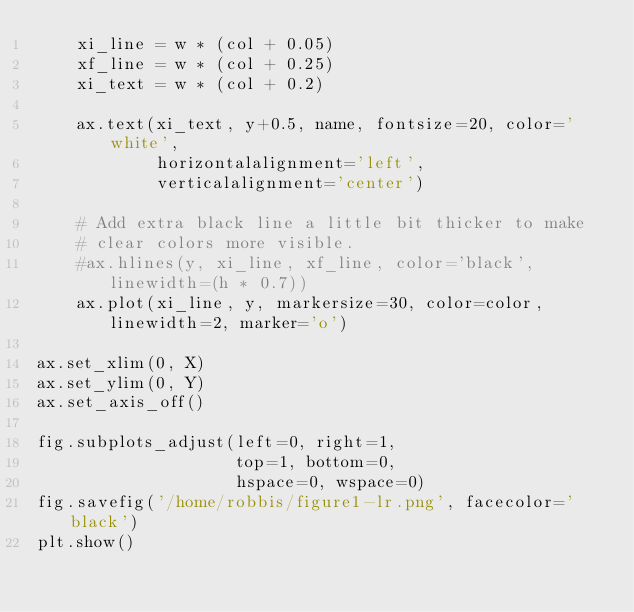Convert code to text. <code><loc_0><loc_0><loc_500><loc_500><_Python_>    xi_line = w * (col + 0.05)
    xf_line = w * (col + 0.25)
    xi_text = w * (col + 0.2)

    ax.text(xi_text, y+0.5, name, fontsize=20, color='white',
            horizontalalignment='left',
            verticalalignment='center')

    # Add extra black line a little bit thicker to make
    # clear colors more visible.
    #ax.hlines(y, xi_line, xf_line, color='black', linewidth=(h * 0.7))
    ax.plot(xi_line, y, markersize=30, color=color, linewidth=2, marker='o')

ax.set_xlim(0, X)
ax.set_ylim(0, Y)
ax.set_axis_off()

fig.subplots_adjust(left=0, right=1,
                    top=1, bottom=0,
                    hspace=0, wspace=0)
fig.savefig('/home/robbis/figure1-lr.png', facecolor='black')
plt.show()</code> 